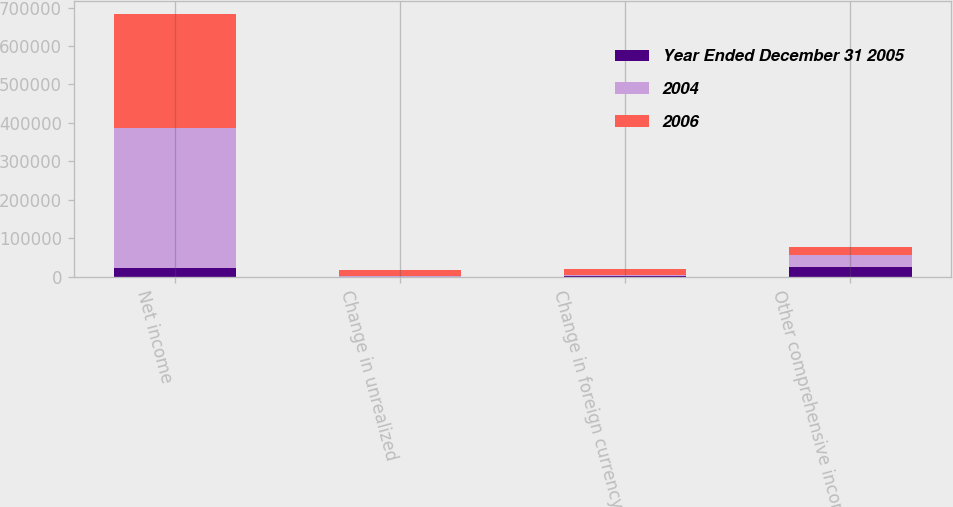Convert chart. <chart><loc_0><loc_0><loc_500><loc_500><stacked_bar_chart><ecel><fcel>Net income<fcel>Change in unrealized<fcel>Change in foreign currency<fcel>Other comprehensive income<nl><fcel>Year Ended December 31 2005<fcel>22368<fcel>143<fcel>2503<fcel>23821<nl><fcel>2004<fcel>363628<fcel>2536<fcel>2040<fcel>31265<nl><fcel>2006<fcel>297137<fcel>15102<fcel>15675<fcel>20915<nl></chart> 